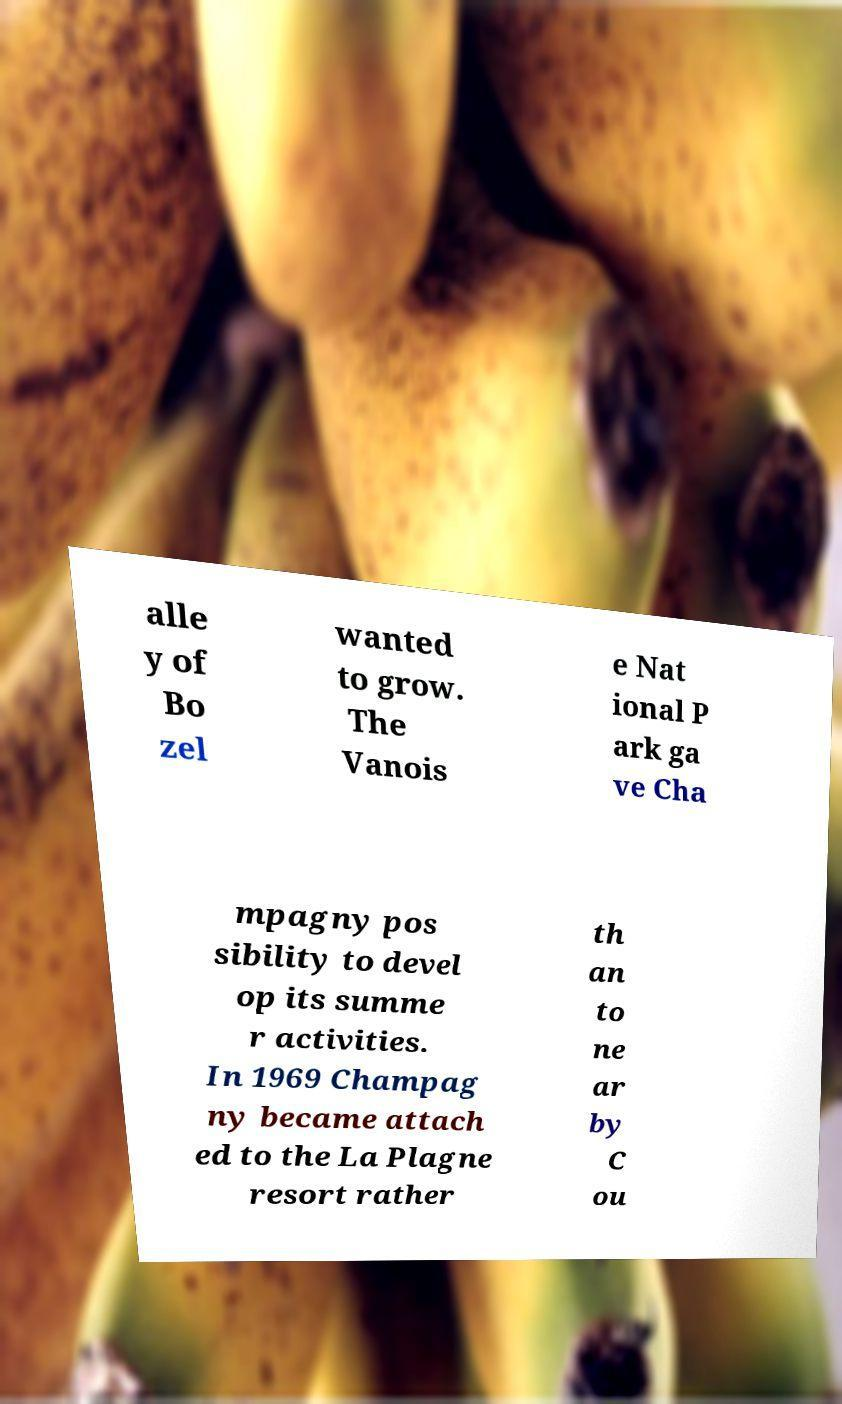Could you extract and type out the text from this image? alle y of Bo zel wanted to grow. The Vanois e Nat ional P ark ga ve Cha mpagny pos sibility to devel op its summe r activities. In 1969 Champag ny became attach ed to the La Plagne resort rather th an to ne ar by C ou 